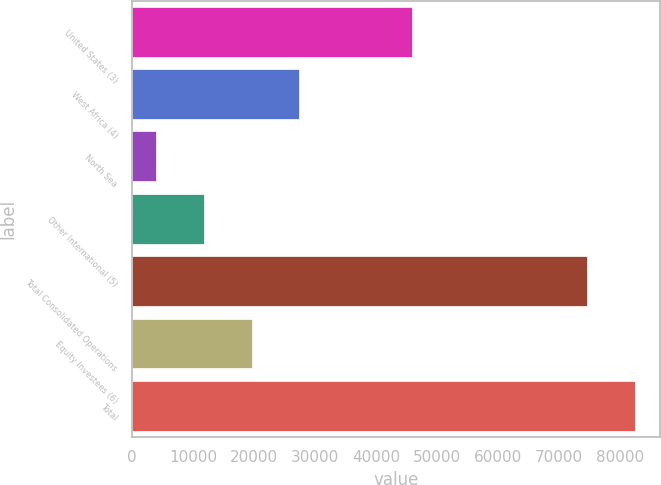<chart> <loc_0><loc_0><loc_500><loc_500><bar_chart><fcel>United States (3)<fcel>West Africa (4)<fcel>North Sea<fcel>Other International (5)<fcel>Total Consolidated Operations<fcel>Equity Investees (6)<fcel>Total<nl><fcel>45798<fcel>27431.8<fcel>3988<fcel>11802.6<fcel>74603<fcel>19617.2<fcel>82417.6<nl></chart> 